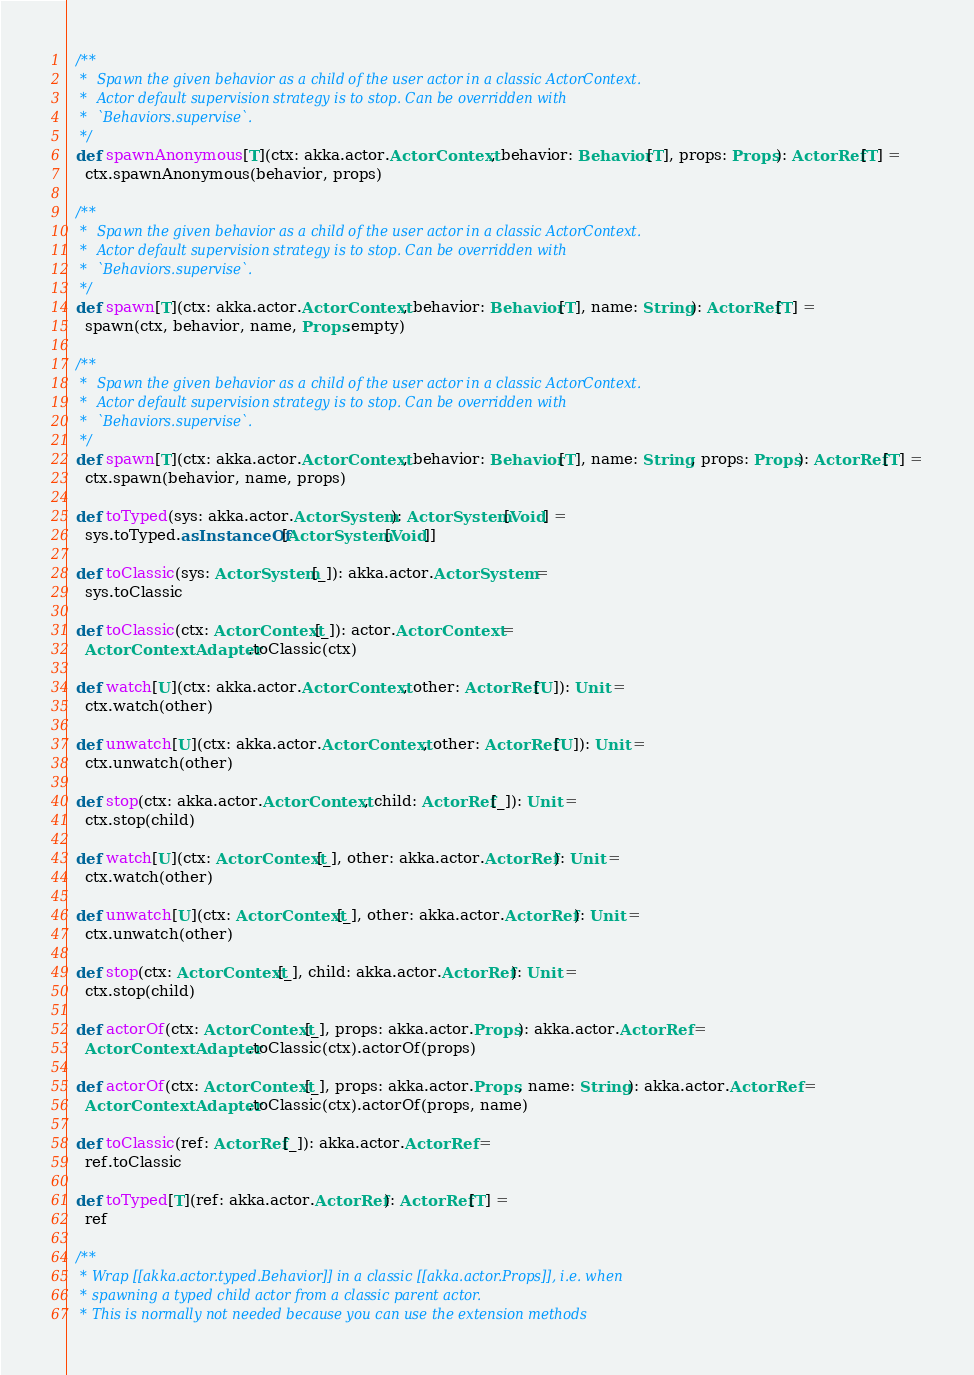Convert code to text. <code><loc_0><loc_0><loc_500><loc_500><_Scala_>
  /**
   *  Spawn the given behavior as a child of the user actor in a classic ActorContext.
   *  Actor default supervision strategy is to stop. Can be overridden with
   *  `Behaviors.supervise`.
   */
  def spawnAnonymous[T](ctx: akka.actor.ActorContext, behavior: Behavior[T], props: Props): ActorRef[T] =
    ctx.spawnAnonymous(behavior, props)

  /**
   *  Spawn the given behavior as a child of the user actor in a classic ActorContext.
   *  Actor default supervision strategy is to stop. Can be overridden with
   *  `Behaviors.supervise`.
   */
  def spawn[T](ctx: akka.actor.ActorContext, behavior: Behavior[T], name: String): ActorRef[T] =
    spawn(ctx, behavior, name, Props.empty)

  /**
   *  Spawn the given behavior as a child of the user actor in a classic ActorContext.
   *  Actor default supervision strategy is to stop. Can be overridden with
   *  `Behaviors.supervise`.
   */
  def spawn[T](ctx: akka.actor.ActorContext, behavior: Behavior[T], name: String, props: Props): ActorRef[T] =
    ctx.spawn(behavior, name, props)

  def toTyped(sys: akka.actor.ActorSystem): ActorSystem[Void] =
    sys.toTyped.asInstanceOf[ActorSystem[Void]]

  def toClassic(sys: ActorSystem[_]): akka.actor.ActorSystem =
    sys.toClassic

  def toClassic(ctx: ActorContext[_]): actor.ActorContext =
    ActorContextAdapter.toClassic(ctx)

  def watch[U](ctx: akka.actor.ActorContext, other: ActorRef[U]): Unit =
    ctx.watch(other)

  def unwatch[U](ctx: akka.actor.ActorContext, other: ActorRef[U]): Unit =
    ctx.unwatch(other)

  def stop(ctx: akka.actor.ActorContext, child: ActorRef[_]): Unit =
    ctx.stop(child)

  def watch[U](ctx: ActorContext[_], other: akka.actor.ActorRef): Unit =
    ctx.watch(other)

  def unwatch[U](ctx: ActorContext[_], other: akka.actor.ActorRef): Unit =
    ctx.unwatch(other)

  def stop(ctx: ActorContext[_], child: akka.actor.ActorRef): Unit =
    ctx.stop(child)

  def actorOf(ctx: ActorContext[_], props: akka.actor.Props): akka.actor.ActorRef =
    ActorContextAdapter.toClassic(ctx).actorOf(props)

  def actorOf(ctx: ActorContext[_], props: akka.actor.Props, name: String): akka.actor.ActorRef =
    ActorContextAdapter.toClassic(ctx).actorOf(props, name)

  def toClassic(ref: ActorRef[_]): akka.actor.ActorRef =
    ref.toClassic

  def toTyped[T](ref: akka.actor.ActorRef): ActorRef[T] =
    ref

  /**
   * Wrap [[akka.actor.typed.Behavior]] in a classic [[akka.actor.Props]], i.e. when
   * spawning a typed child actor from a classic parent actor.
   * This is normally not needed because you can use the extension methods</code> 